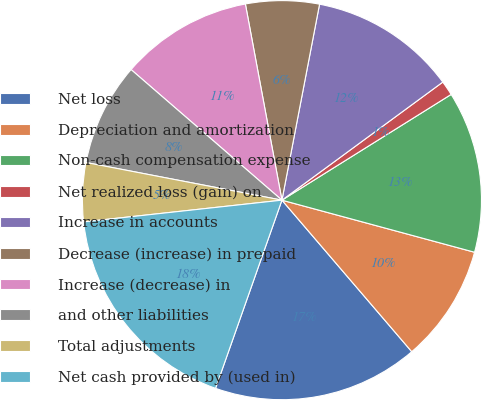<chart> <loc_0><loc_0><loc_500><loc_500><pie_chart><fcel>Net loss<fcel>Depreciation and amortization<fcel>Non-cash compensation expense<fcel>Net realized loss (gain) on<fcel>Increase in accounts<fcel>Decrease (increase) in prepaid<fcel>Increase (decrease) in<fcel>and other liabilities<fcel>Total adjustments<fcel>Net cash provided by (used in)<nl><fcel>16.67%<fcel>9.52%<fcel>13.09%<fcel>1.19%<fcel>11.9%<fcel>5.95%<fcel>10.71%<fcel>8.33%<fcel>4.76%<fcel>17.86%<nl></chart> 